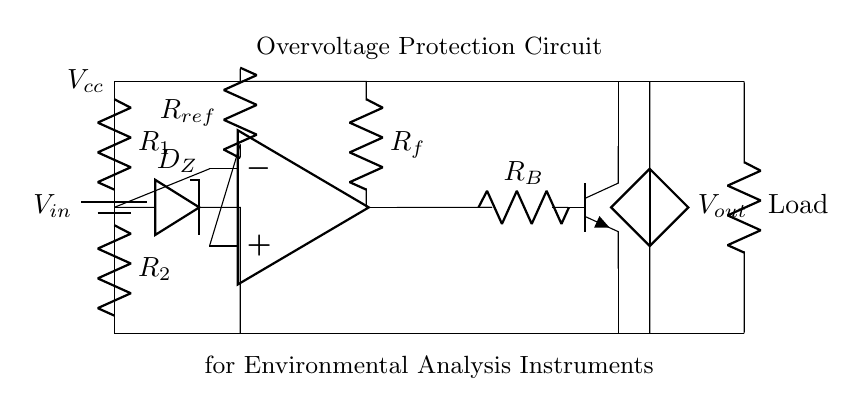What type of diodes are used in this circuit? The circuit contains a Zener diode labeled as D_Z, which is specifically used for voltage regulation and overvoltage protection.
Answer: Zener diode What is the purpose of the comparator in this circuit? The comparator compares the voltage at its inverting terminal with the reference voltage from R_ref. If the input voltage exceeds a certain threshold, it signals the transistor to activate, providing overvoltage protection.
Answer: To provide voltage comparison What does R_1 and R_2 form in this circuit? R_1 and R_2 form a voltage divider that reduces the input voltage to a level suitable for comparison with the reference voltage.
Answer: A voltage divider What happens when the input voltage exceeds the Zener breakdown voltage? When the input voltage exceeds the Zener breakdown voltage, the Zener diode conducts, preventing the voltage from reaching the sensitive load, thereby protecting it.
Answer: The Zener diode conducts What component acts as the switching element in this circuit? The switching element in this circuit is the NPN transistor, which is controlled by the output of the comparator to turn on or off the protection.
Answer: NPN transistor What is the role of the load in the circuit? The load represents the sensitive analytical instruments that require protection from overvoltage to ensure their proper functioning during environmental assessments.
Answer: Sensitive analytical instruments 